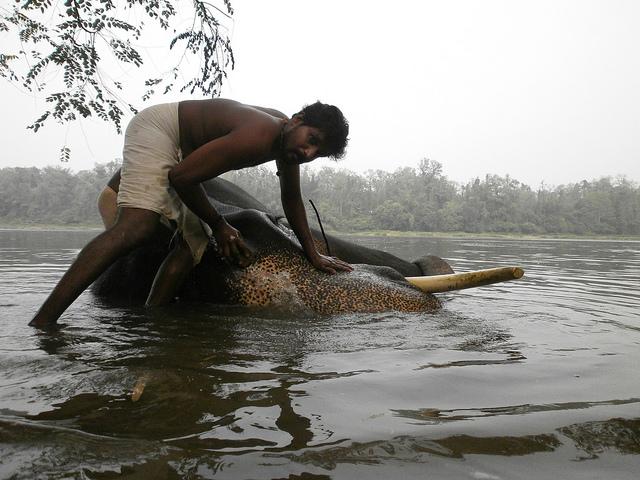Does the boy have brown skin?
Be succinct. Yes. What is the boy touching?
Concise answer only. Elephant. Is the man shirtless?
Give a very brief answer. Yes. 